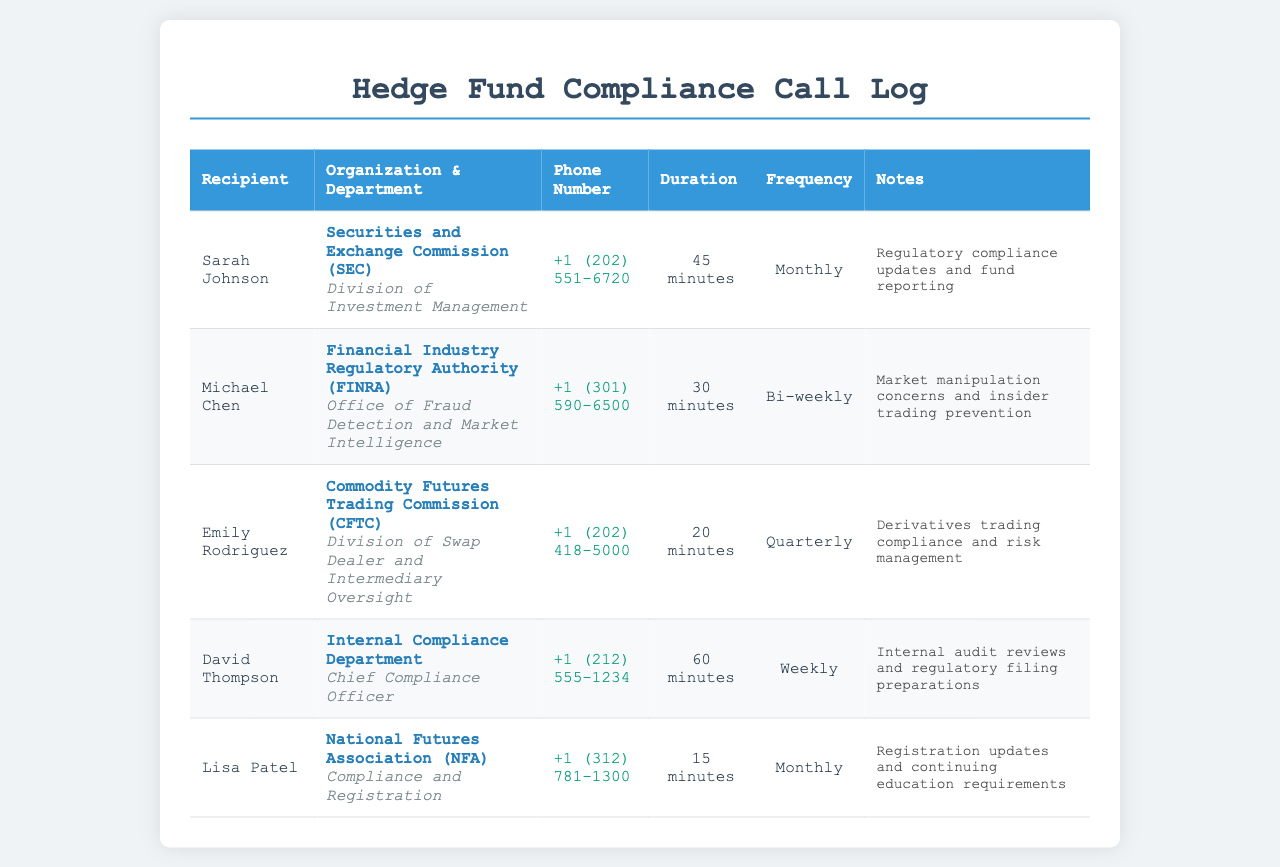what is the name of the recipient from the SEC? The document lists Sarah Johnson as the recipient from the Securities and Exchange Commission (SEC).
Answer: Sarah Johnson how long is the call duration with FINRA? The document states the call duration with FINRA is 30 minutes.
Answer: 30 minutes how frequently are calls made to the Internal Compliance Department? The log indicates that calls to the Internal Compliance Department occur weekly.
Answer: Weekly what is the phone number for the CFTC? The document provides the phone number for the Commodity Futures Trading Commission (CFTC) as +1 (202) 418-5000.
Answer: +1 (202) 418-5000 which organization is related to market manipulation concerns? The call log indicates the Financial Industry Regulatory Authority (FINRA) addresses market manipulation concerns.
Answer: Financial Industry Regulatory Authority (FINRA) how many minutes is the regular call duration with the NFA? The document specifies that the call duration with the National Futures Association (NFA) is 15 minutes.
Answer: 15 minutes what is the purpose of the calls with the SEC? According to the notes, the calls with the SEC focus on regulatory compliance updates and fund reporting.
Answer: Regulatory compliance updates and fund reporting which department does Emily Rodriguez work in? The document mentions that Emily Rodriguez works in the Division of Swap Dealer and Intermediary Oversight.
Answer: Division of Swap Dealer and Intermediary Oversight who is the Chief Compliance Officer? The document lists David Thompson as the Chief Compliance Officer in the Internal Compliance Department.
Answer: David Thompson 